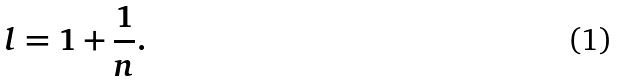<formula> <loc_0><loc_0><loc_500><loc_500>l = 1 + \frac { 1 } { n } .</formula> 